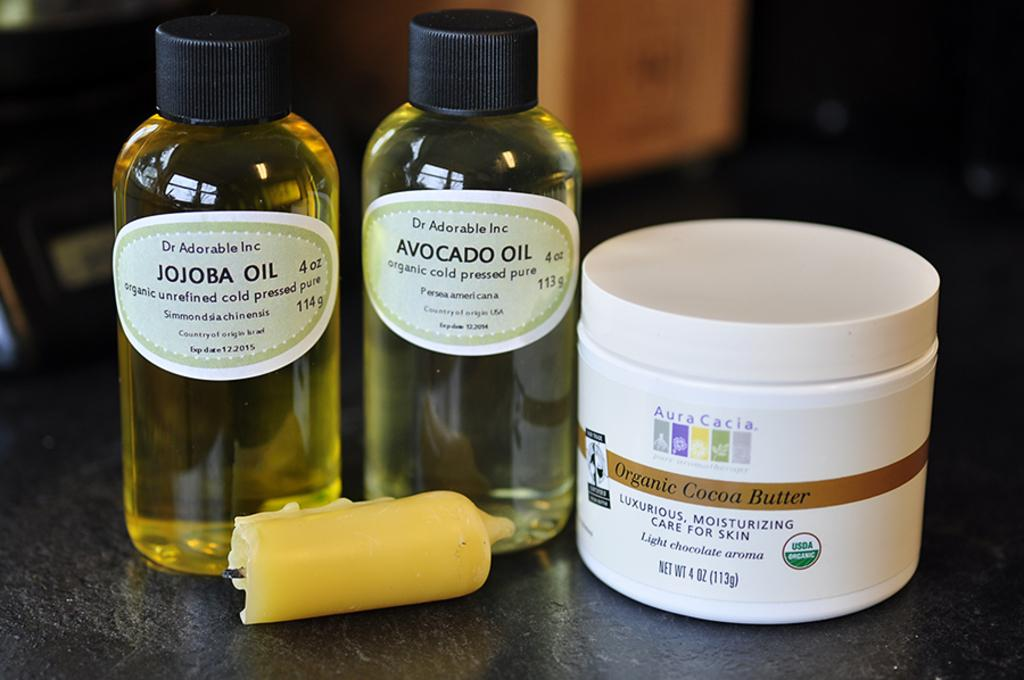<image>
Create a compact narrative representing the image presented. Bottles of liquid and a jar of a substance that can be used to assist in human skin care by reading the labels on the containers. 